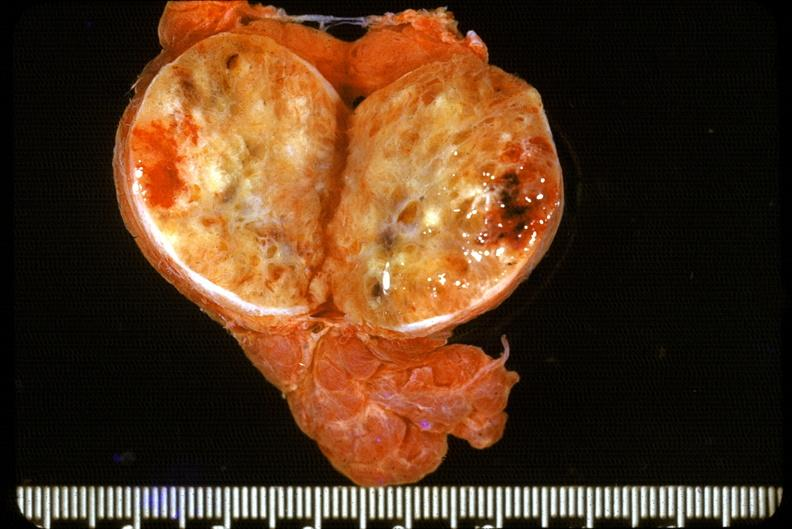does peritoneum show thyroid, follicular adenoma?
Answer the question using a single word or phrase. No 